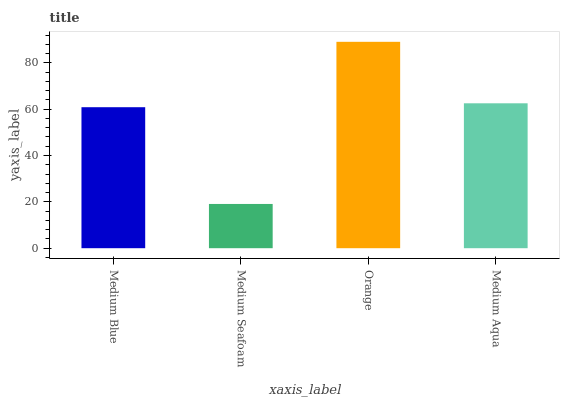Is Orange the minimum?
Answer yes or no. No. Is Medium Seafoam the maximum?
Answer yes or no. No. Is Orange greater than Medium Seafoam?
Answer yes or no. Yes. Is Medium Seafoam less than Orange?
Answer yes or no. Yes. Is Medium Seafoam greater than Orange?
Answer yes or no. No. Is Orange less than Medium Seafoam?
Answer yes or no. No. Is Medium Aqua the high median?
Answer yes or no. Yes. Is Medium Blue the low median?
Answer yes or no. Yes. Is Medium Seafoam the high median?
Answer yes or no. No. Is Orange the low median?
Answer yes or no. No. 